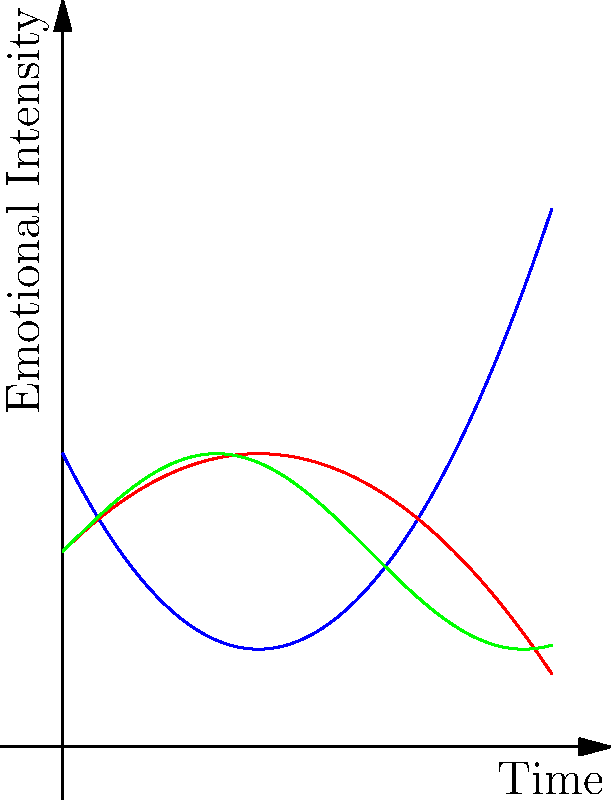Analyze the line graphs representing the emotional journeys of three different narrators (A, B, and C) in a novel. Which narrator experiences the most dramatic emotional shift, and how might this impact the reader's engagement with the story? To answer this question, we need to examine each narrator's emotional journey:

1. Narrator A (Blue line):
   - Starts at a moderate emotional intensity
   - Experiences a slight dip initially
   - Then shows a sharp increase in emotional intensity

2. Narrator B (Red line):
   - Begins at a relatively high emotional intensity
   - Gradually increases to a peak
   - Then shows a steady decline

3. Narrator C (Green line):
   - Starts at a moderate emotional intensity
   - Experiences regular fluctuations throughout the story

Comparing these journeys:
- Narrator A shows the most dramatic shift, starting low and ending very high
- Narrator B has a notable arc but less dramatic than A
- Narrator C maintains a consistent level of fluctuation

The impact on reader engagement:
- Narrator A's dramatic shift is likely to create the most tension and surprise for readers
- This sudden intensification of emotions can lead to increased reader investment in the character's journey
- The contrast between the initial calm and final intensity may provoke deeper reflection on the events that caused such a significant change

Therefore, Narrator A's emotional journey is likely to have the strongest impact on reader engagement due to its dramatic shift and potential for creating tension and reflection.
Answer: Narrator A, due to the sharp increase in emotional intensity 